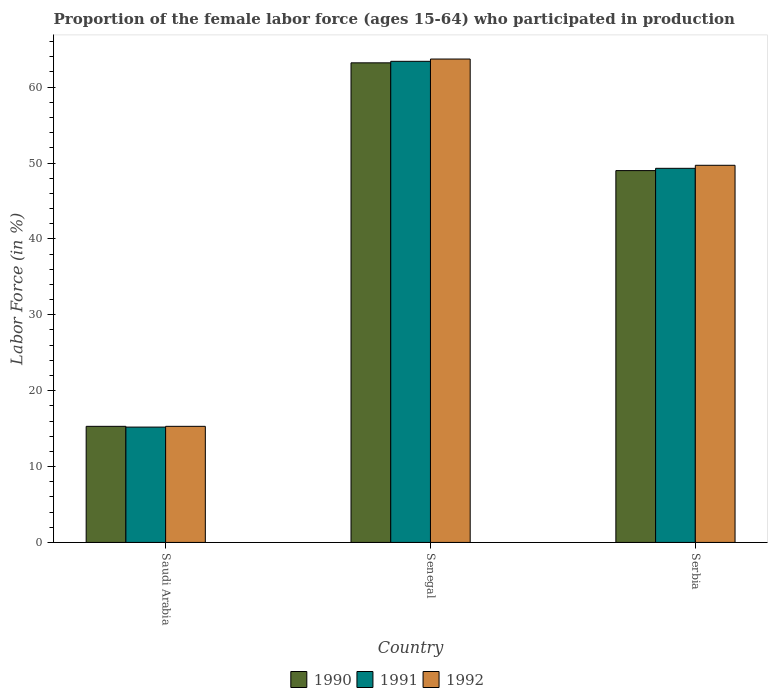How many different coloured bars are there?
Make the answer very short. 3. How many groups of bars are there?
Offer a very short reply. 3. How many bars are there on the 3rd tick from the left?
Give a very brief answer. 3. What is the label of the 2nd group of bars from the left?
Keep it short and to the point. Senegal. What is the proportion of the female labor force who participated in production in 1992 in Saudi Arabia?
Offer a terse response. 15.3. Across all countries, what is the maximum proportion of the female labor force who participated in production in 1990?
Give a very brief answer. 63.2. Across all countries, what is the minimum proportion of the female labor force who participated in production in 1991?
Your response must be concise. 15.2. In which country was the proportion of the female labor force who participated in production in 1992 maximum?
Keep it short and to the point. Senegal. In which country was the proportion of the female labor force who participated in production in 1991 minimum?
Your answer should be compact. Saudi Arabia. What is the total proportion of the female labor force who participated in production in 1991 in the graph?
Offer a terse response. 127.9. What is the difference between the proportion of the female labor force who participated in production in 1991 in Saudi Arabia and that in Serbia?
Provide a short and direct response. -34.1. What is the difference between the proportion of the female labor force who participated in production in 1991 in Serbia and the proportion of the female labor force who participated in production in 1990 in Senegal?
Ensure brevity in your answer.  -13.9. What is the average proportion of the female labor force who participated in production in 1992 per country?
Give a very brief answer. 42.9. What is the difference between the proportion of the female labor force who participated in production of/in 1990 and proportion of the female labor force who participated in production of/in 1992 in Serbia?
Provide a short and direct response. -0.7. What is the ratio of the proportion of the female labor force who participated in production in 1992 in Saudi Arabia to that in Senegal?
Keep it short and to the point. 0.24. Is the difference between the proportion of the female labor force who participated in production in 1990 in Saudi Arabia and Senegal greater than the difference between the proportion of the female labor force who participated in production in 1992 in Saudi Arabia and Senegal?
Your answer should be very brief. Yes. What is the difference between the highest and the second highest proportion of the female labor force who participated in production in 1990?
Keep it short and to the point. 33.7. What is the difference between the highest and the lowest proportion of the female labor force who participated in production in 1992?
Your answer should be compact. 48.4. In how many countries, is the proportion of the female labor force who participated in production in 1991 greater than the average proportion of the female labor force who participated in production in 1991 taken over all countries?
Offer a terse response. 2. How many bars are there?
Your answer should be very brief. 9. Are all the bars in the graph horizontal?
Offer a very short reply. No. How many countries are there in the graph?
Make the answer very short. 3. Are the values on the major ticks of Y-axis written in scientific E-notation?
Offer a very short reply. No. Does the graph contain any zero values?
Give a very brief answer. No. Does the graph contain grids?
Provide a short and direct response. No. How many legend labels are there?
Provide a short and direct response. 3. How are the legend labels stacked?
Make the answer very short. Horizontal. What is the title of the graph?
Make the answer very short. Proportion of the female labor force (ages 15-64) who participated in production. Does "1965" appear as one of the legend labels in the graph?
Keep it short and to the point. No. What is the label or title of the Y-axis?
Offer a very short reply. Labor Force (in %). What is the Labor Force (in %) of 1990 in Saudi Arabia?
Keep it short and to the point. 15.3. What is the Labor Force (in %) of 1991 in Saudi Arabia?
Make the answer very short. 15.2. What is the Labor Force (in %) of 1992 in Saudi Arabia?
Ensure brevity in your answer.  15.3. What is the Labor Force (in %) in 1990 in Senegal?
Your answer should be very brief. 63.2. What is the Labor Force (in %) of 1991 in Senegal?
Offer a very short reply. 63.4. What is the Labor Force (in %) of 1992 in Senegal?
Offer a very short reply. 63.7. What is the Labor Force (in %) in 1991 in Serbia?
Ensure brevity in your answer.  49.3. What is the Labor Force (in %) of 1992 in Serbia?
Keep it short and to the point. 49.7. Across all countries, what is the maximum Labor Force (in %) in 1990?
Offer a very short reply. 63.2. Across all countries, what is the maximum Labor Force (in %) of 1991?
Give a very brief answer. 63.4. Across all countries, what is the maximum Labor Force (in %) in 1992?
Give a very brief answer. 63.7. Across all countries, what is the minimum Labor Force (in %) of 1990?
Provide a succinct answer. 15.3. Across all countries, what is the minimum Labor Force (in %) of 1991?
Your answer should be very brief. 15.2. Across all countries, what is the minimum Labor Force (in %) of 1992?
Provide a short and direct response. 15.3. What is the total Labor Force (in %) of 1990 in the graph?
Your answer should be very brief. 127.5. What is the total Labor Force (in %) of 1991 in the graph?
Give a very brief answer. 127.9. What is the total Labor Force (in %) of 1992 in the graph?
Your answer should be compact. 128.7. What is the difference between the Labor Force (in %) of 1990 in Saudi Arabia and that in Senegal?
Your answer should be very brief. -47.9. What is the difference between the Labor Force (in %) of 1991 in Saudi Arabia and that in Senegal?
Keep it short and to the point. -48.2. What is the difference between the Labor Force (in %) in 1992 in Saudi Arabia and that in Senegal?
Offer a very short reply. -48.4. What is the difference between the Labor Force (in %) in 1990 in Saudi Arabia and that in Serbia?
Make the answer very short. -33.7. What is the difference between the Labor Force (in %) in 1991 in Saudi Arabia and that in Serbia?
Provide a short and direct response. -34.1. What is the difference between the Labor Force (in %) of 1992 in Saudi Arabia and that in Serbia?
Keep it short and to the point. -34.4. What is the difference between the Labor Force (in %) of 1990 in Senegal and that in Serbia?
Offer a very short reply. 14.2. What is the difference between the Labor Force (in %) of 1990 in Saudi Arabia and the Labor Force (in %) of 1991 in Senegal?
Provide a short and direct response. -48.1. What is the difference between the Labor Force (in %) in 1990 in Saudi Arabia and the Labor Force (in %) in 1992 in Senegal?
Give a very brief answer. -48.4. What is the difference between the Labor Force (in %) in 1991 in Saudi Arabia and the Labor Force (in %) in 1992 in Senegal?
Give a very brief answer. -48.5. What is the difference between the Labor Force (in %) in 1990 in Saudi Arabia and the Labor Force (in %) in 1991 in Serbia?
Provide a short and direct response. -34. What is the difference between the Labor Force (in %) of 1990 in Saudi Arabia and the Labor Force (in %) of 1992 in Serbia?
Offer a terse response. -34.4. What is the difference between the Labor Force (in %) of 1991 in Saudi Arabia and the Labor Force (in %) of 1992 in Serbia?
Your answer should be compact. -34.5. What is the difference between the Labor Force (in %) in 1991 in Senegal and the Labor Force (in %) in 1992 in Serbia?
Your answer should be compact. 13.7. What is the average Labor Force (in %) of 1990 per country?
Your response must be concise. 42.5. What is the average Labor Force (in %) of 1991 per country?
Make the answer very short. 42.63. What is the average Labor Force (in %) of 1992 per country?
Ensure brevity in your answer.  42.9. What is the difference between the Labor Force (in %) of 1990 and Labor Force (in %) of 1991 in Saudi Arabia?
Your response must be concise. 0.1. What is the difference between the Labor Force (in %) of 1990 and Labor Force (in %) of 1992 in Saudi Arabia?
Offer a terse response. 0. What is the difference between the Labor Force (in %) in 1991 and Labor Force (in %) in 1992 in Saudi Arabia?
Your answer should be very brief. -0.1. What is the difference between the Labor Force (in %) of 1990 and Labor Force (in %) of 1991 in Senegal?
Offer a terse response. -0.2. What is the difference between the Labor Force (in %) of 1990 and Labor Force (in %) of 1992 in Serbia?
Give a very brief answer. -0.7. What is the difference between the Labor Force (in %) in 1991 and Labor Force (in %) in 1992 in Serbia?
Ensure brevity in your answer.  -0.4. What is the ratio of the Labor Force (in %) in 1990 in Saudi Arabia to that in Senegal?
Give a very brief answer. 0.24. What is the ratio of the Labor Force (in %) of 1991 in Saudi Arabia to that in Senegal?
Give a very brief answer. 0.24. What is the ratio of the Labor Force (in %) of 1992 in Saudi Arabia to that in Senegal?
Keep it short and to the point. 0.24. What is the ratio of the Labor Force (in %) in 1990 in Saudi Arabia to that in Serbia?
Ensure brevity in your answer.  0.31. What is the ratio of the Labor Force (in %) of 1991 in Saudi Arabia to that in Serbia?
Provide a short and direct response. 0.31. What is the ratio of the Labor Force (in %) of 1992 in Saudi Arabia to that in Serbia?
Keep it short and to the point. 0.31. What is the ratio of the Labor Force (in %) in 1990 in Senegal to that in Serbia?
Offer a terse response. 1.29. What is the ratio of the Labor Force (in %) of 1991 in Senegal to that in Serbia?
Provide a succinct answer. 1.29. What is the ratio of the Labor Force (in %) of 1992 in Senegal to that in Serbia?
Provide a succinct answer. 1.28. What is the difference between the highest and the lowest Labor Force (in %) in 1990?
Give a very brief answer. 47.9. What is the difference between the highest and the lowest Labor Force (in %) in 1991?
Provide a short and direct response. 48.2. What is the difference between the highest and the lowest Labor Force (in %) in 1992?
Ensure brevity in your answer.  48.4. 